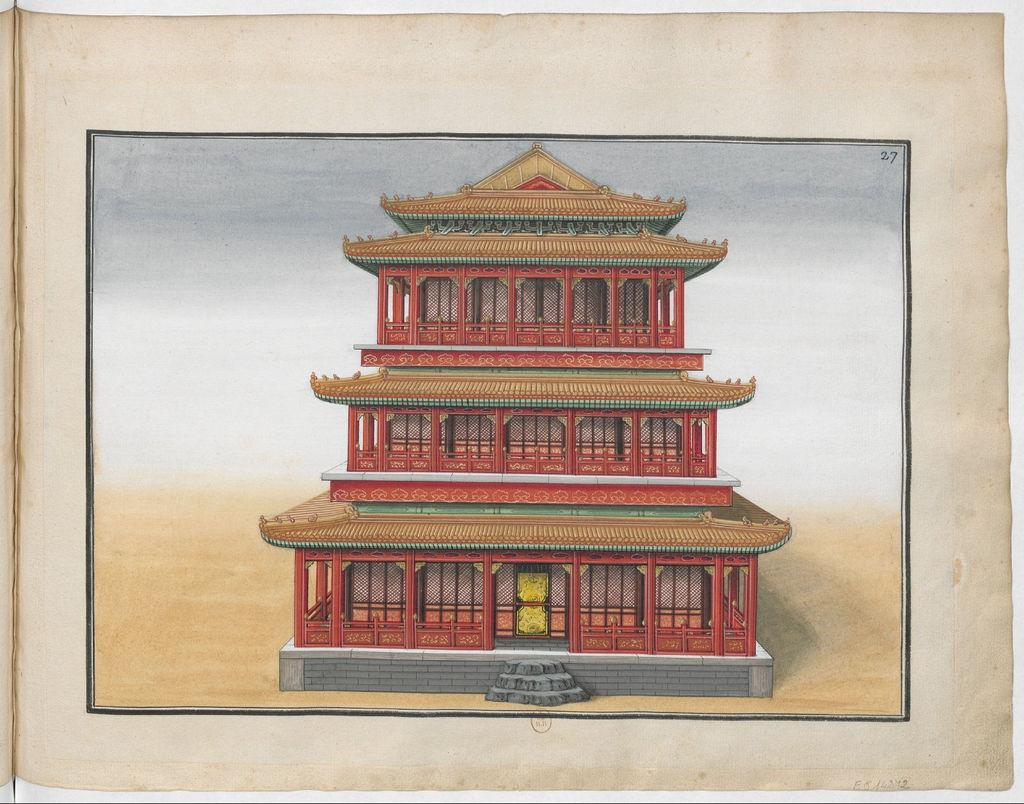What is depicted on the paper in the image? The paper contains a drawing or image of a building. What type of surface is visible beneath the paper? There is ground visible in the image. What else can be seen in the background of the image? The sky is visible in the image. What type of feast is being prepared on the wall in the image? There is no wall or feast present in the image; it only features a paper with a drawing or image of a building. 